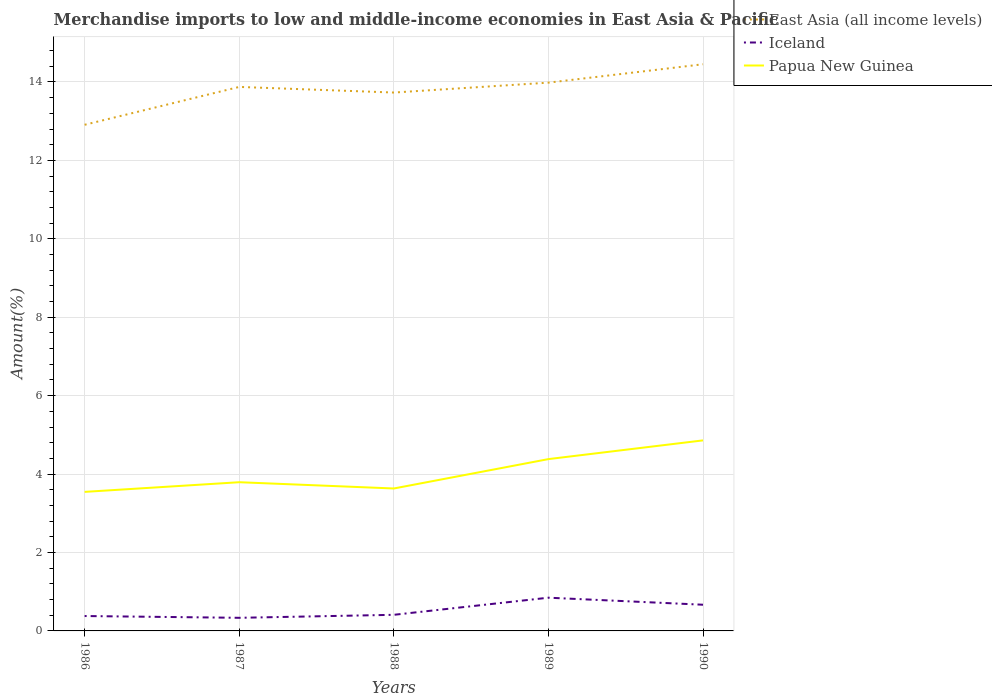How many different coloured lines are there?
Offer a very short reply. 3. Does the line corresponding to Papua New Guinea intersect with the line corresponding to Iceland?
Your response must be concise. No. Across all years, what is the maximum percentage of amount earned from merchandise imports in Iceland?
Make the answer very short. 0.33. What is the total percentage of amount earned from merchandise imports in Papua New Guinea in the graph?
Provide a short and direct response. -0.84. What is the difference between the highest and the second highest percentage of amount earned from merchandise imports in East Asia (all income levels)?
Offer a very short reply. 1.54. Is the percentage of amount earned from merchandise imports in Papua New Guinea strictly greater than the percentage of amount earned from merchandise imports in East Asia (all income levels) over the years?
Offer a very short reply. Yes. How many lines are there?
Offer a terse response. 3. What is the difference between two consecutive major ticks on the Y-axis?
Offer a very short reply. 2. Where does the legend appear in the graph?
Offer a very short reply. Top right. How are the legend labels stacked?
Offer a very short reply. Vertical. What is the title of the graph?
Your answer should be very brief. Merchandise imports to low and middle-income economies in East Asia & Pacific. What is the label or title of the X-axis?
Your answer should be compact. Years. What is the label or title of the Y-axis?
Offer a very short reply. Amount(%). What is the Amount(%) of East Asia (all income levels) in 1986?
Offer a very short reply. 12.91. What is the Amount(%) of Iceland in 1986?
Provide a short and direct response. 0.38. What is the Amount(%) of Papua New Guinea in 1986?
Give a very brief answer. 3.55. What is the Amount(%) of East Asia (all income levels) in 1987?
Your response must be concise. 13.87. What is the Amount(%) in Iceland in 1987?
Your response must be concise. 0.33. What is the Amount(%) in Papua New Guinea in 1987?
Offer a very short reply. 3.79. What is the Amount(%) in East Asia (all income levels) in 1988?
Offer a terse response. 13.73. What is the Amount(%) of Iceland in 1988?
Offer a terse response. 0.41. What is the Amount(%) of Papua New Guinea in 1988?
Provide a succinct answer. 3.63. What is the Amount(%) of East Asia (all income levels) in 1989?
Your answer should be very brief. 13.98. What is the Amount(%) of Iceland in 1989?
Make the answer very short. 0.85. What is the Amount(%) of Papua New Guinea in 1989?
Your response must be concise. 4.38. What is the Amount(%) of East Asia (all income levels) in 1990?
Provide a succinct answer. 14.45. What is the Amount(%) of Iceland in 1990?
Make the answer very short. 0.67. What is the Amount(%) of Papua New Guinea in 1990?
Your answer should be very brief. 4.86. Across all years, what is the maximum Amount(%) in East Asia (all income levels)?
Your answer should be very brief. 14.45. Across all years, what is the maximum Amount(%) in Iceland?
Ensure brevity in your answer.  0.85. Across all years, what is the maximum Amount(%) of Papua New Guinea?
Your response must be concise. 4.86. Across all years, what is the minimum Amount(%) in East Asia (all income levels)?
Make the answer very short. 12.91. Across all years, what is the minimum Amount(%) of Iceland?
Offer a terse response. 0.33. Across all years, what is the minimum Amount(%) of Papua New Guinea?
Give a very brief answer. 3.55. What is the total Amount(%) in East Asia (all income levels) in the graph?
Ensure brevity in your answer.  68.94. What is the total Amount(%) in Iceland in the graph?
Give a very brief answer. 2.64. What is the total Amount(%) in Papua New Guinea in the graph?
Keep it short and to the point. 20.21. What is the difference between the Amount(%) in East Asia (all income levels) in 1986 and that in 1987?
Make the answer very short. -0.97. What is the difference between the Amount(%) of Iceland in 1986 and that in 1987?
Make the answer very short. 0.05. What is the difference between the Amount(%) of Papua New Guinea in 1986 and that in 1987?
Your response must be concise. -0.25. What is the difference between the Amount(%) of East Asia (all income levels) in 1986 and that in 1988?
Give a very brief answer. -0.82. What is the difference between the Amount(%) in Iceland in 1986 and that in 1988?
Keep it short and to the point. -0.03. What is the difference between the Amount(%) in Papua New Guinea in 1986 and that in 1988?
Give a very brief answer. -0.09. What is the difference between the Amount(%) of East Asia (all income levels) in 1986 and that in 1989?
Offer a very short reply. -1.07. What is the difference between the Amount(%) of Iceland in 1986 and that in 1989?
Make the answer very short. -0.47. What is the difference between the Amount(%) in Papua New Guinea in 1986 and that in 1989?
Offer a terse response. -0.84. What is the difference between the Amount(%) of East Asia (all income levels) in 1986 and that in 1990?
Provide a succinct answer. -1.54. What is the difference between the Amount(%) of Iceland in 1986 and that in 1990?
Give a very brief answer. -0.29. What is the difference between the Amount(%) of Papua New Guinea in 1986 and that in 1990?
Provide a short and direct response. -1.31. What is the difference between the Amount(%) in East Asia (all income levels) in 1987 and that in 1988?
Keep it short and to the point. 0.14. What is the difference between the Amount(%) of Iceland in 1987 and that in 1988?
Your answer should be very brief. -0.08. What is the difference between the Amount(%) in Papua New Guinea in 1987 and that in 1988?
Provide a short and direct response. 0.16. What is the difference between the Amount(%) in East Asia (all income levels) in 1987 and that in 1989?
Provide a succinct answer. -0.11. What is the difference between the Amount(%) in Iceland in 1987 and that in 1989?
Keep it short and to the point. -0.51. What is the difference between the Amount(%) in Papua New Guinea in 1987 and that in 1989?
Your answer should be compact. -0.59. What is the difference between the Amount(%) in East Asia (all income levels) in 1987 and that in 1990?
Offer a very short reply. -0.58. What is the difference between the Amount(%) in Iceland in 1987 and that in 1990?
Your answer should be compact. -0.33. What is the difference between the Amount(%) in Papua New Guinea in 1987 and that in 1990?
Your response must be concise. -1.07. What is the difference between the Amount(%) in East Asia (all income levels) in 1988 and that in 1989?
Keep it short and to the point. -0.25. What is the difference between the Amount(%) of Iceland in 1988 and that in 1989?
Give a very brief answer. -0.44. What is the difference between the Amount(%) of Papua New Guinea in 1988 and that in 1989?
Provide a short and direct response. -0.75. What is the difference between the Amount(%) in East Asia (all income levels) in 1988 and that in 1990?
Provide a short and direct response. -0.72. What is the difference between the Amount(%) of Iceland in 1988 and that in 1990?
Your answer should be compact. -0.26. What is the difference between the Amount(%) in Papua New Guinea in 1988 and that in 1990?
Ensure brevity in your answer.  -1.23. What is the difference between the Amount(%) of East Asia (all income levels) in 1989 and that in 1990?
Provide a succinct answer. -0.47. What is the difference between the Amount(%) of Iceland in 1989 and that in 1990?
Make the answer very short. 0.18. What is the difference between the Amount(%) in Papua New Guinea in 1989 and that in 1990?
Your response must be concise. -0.48. What is the difference between the Amount(%) of East Asia (all income levels) in 1986 and the Amount(%) of Iceland in 1987?
Make the answer very short. 12.57. What is the difference between the Amount(%) of East Asia (all income levels) in 1986 and the Amount(%) of Papua New Guinea in 1987?
Make the answer very short. 9.12. What is the difference between the Amount(%) of Iceland in 1986 and the Amount(%) of Papua New Guinea in 1987?
Give a very brief answer. -3.41. What is the difference between the Amount(%) in East Asia (all income levels) in 1986 and the Amount(%) in Iceland in 1988?
Ensure brevity in your answer.  12.5. What is the difference between the Amount(%) of East Asia (all income levels) in 1986 and the Amount(%) of Papua New Guinea in 1988?
Keep it short and to the point. 9.28. What is the difference between the Amount(%) of Iceland in 1986 and the Amount(%) of Papua New Guinea in 1988?
Provide a succinct answer. -3.25. What is the difference between the Amount(%) of East Asia (all income levels) in 1986 and the Amount(%) of Iceland in 1989?
Your answer should be very brief. 12.06. What is the difference between the Amount(%) in East Asia (all income levels) in 1986 and the Amount(%) in Papua New Guinea in 1989?
Provide a succinct answer. 8.53. What is the difference between the Amount(%) in Iceland in 1986 and the Amount(%) in Papua New Guinea in 1989?
Your answer should be compact. -4. What is the difference between the Amount(%) of East Asia (all income levels) in 1986 and the Amount(%) of Iceland in 1990?
Make the answer very short. 12.24. What is the difference between the Amount(%) in East Asia (all income levels) in 1986 and the Amount(%) in Papua New Guinea in 1990?
Make the answer very short. 8.05. What is the difference between the Amount(%) of Iceland in 1986 and the Amount(%) of Papua New Guinea in 1990?
Your answer should be compact. -4.48. What is the difference between the Amount(%) of East Asia (all income levels) in 1987 and the Amount(%) of Iceland in 1988?
Your answer should be compact. 13.46. What is the difference between the Amount(%) of East Asia (all income levels) in 1987 and the Amount(%) of Papua New Guinea in 1988?
Keep it short and to the point. 10.24. What is the difference between the Amount(%) in Iceland in 1987 and the Amount(%) in Papua New Guinea in 1988?
Your response must be concise. -3.3. What is the difference between the Amount(%) of East Asia (all income levels) in 1987 and the Amount(%) of Iceland in 1989?
Make the answer very short. 13.03. What is the difference between the Amount(%) of East Asia (all income levels) in 1987 and the Amount(%) of Papua New Guinea in 1989?
Your answer should be very brief. 9.49. What is the difference between the Amount(%) of Iceland in 1987 and the Amount(%) of Papua New Guinea in 1989?
Provide a succinct answer. -4.05. What is the difference between the Amount(%) of East Asia (all income levels) in 1987 and the Amount(%) of Iceland in 1990?
Give a very brief answer. 13.21. What is the difference between the Amount(%) of East Asia (all income levels) in 1987 and the Amount(%) of Papua New Guinea in 1990?
Give a very brief answer. 9.01. What is the difference between the Amount(%) of Iceland in 1987 and the Amount(%) of Papua New Guinea in 1990?
Provide a short and direct response. -4.52. What is the difference between the Amount(%) of East Asia (all income levels) in 1988 and the Amount(%) of Iceland in 1989?
Make the answer very short. 12.88. What is the difference between the Amount(%) in East Asia (all income levels) in 1988 and the Amount(%) in Papua New Guinea in 1989?
Offer a very short reply. 9.35. What is the difference between the Amount(%) of Iceland in 1988 and the Amount(%) of Papua New Guinea in 1989?
Offer a very short reply. -3.97. What is the difference between the Amount(%) of East Asia (all income levels) in 1988 and the Amount(%) of Iceland in 1990?
Your response must be concise. 13.06. What is the difference between the Amount(%) of East Asia (all income levels) in 1988 and the Amount(%) of Papua New Guinea in 1990?
Provide a succinct answer. 8.87. What is the difference between the Amount(%) of Iceland in 1988 and the Amount(%) of Papua New Guinea in 1990?
Provide a succinct answer. -4.45. What is the difference between the Amount(%) in East Asia (all income levels) in 1989 and the Amount(%) in Iceland in 1990?
Your response must be concise. 13.31. What is the difference between the Amount(%) of East Asia (all income levels) in 1989 and the Amount(%) of Papua New Guinea in 1990?
Your answer should be very brief. 9.12. What is the difference between the Amount(%) of Iceland in 1989 and the Amount(%) of Papua New Guinea in 1990?
Your answer should be compact. -4.01. What is the average Amount(%) of East Asia (all income levels) per year?
Your answer should be compact. 13.79. What is the average Amount(%) of Iceland per year?
Your answer should be compact. 0.53. What is the average Amount(%) in Papua New Guinea per year?
Give a very brief answer. 4.04. In the year 1986, what is the difference between the Amount(%) of East Asia (all income levels) and Amount(%) of Iceland?
Your response must be concise. 12.53. In the year 1986, what is the difference between the Amount(%) in East Asia (all income levels) and Amount(%) in Papua New Guinea?
Provide a succinct answer. 9.36. In the year 1986, what is the difference between the Amount(%) of Iceland and Amount(%) of Papua New Guinea?
Offer a terse response. -3.17. In the year 1987, what is the difference between the Amount(%) in East Asia (all income levels) and Amount(%) in Iceland?
Make the answer very short. 13.54. In the year 1987, what is the difference between the Amount(%) of East Asia (all income levels) and Amount(%) of Papua New Guinea?
Provide a succinct answer. 10.08. In the year 1987, what is the difference between the Amount(%) of Iceland and Amount(%) of Papua New Guinea?
Provide a short and direct response. -3.46. In the year 1988, what is the difference between the Amount(%) of East Asia (all income levels) and Amount(%) of Iceland?
Offer a terse response. 13.32. In the year 1988, what is the difference between the Amount(%) in East Asia (all income levels) and Amount(%) in Papua New Guinea?
Your answer should be compact. 10.1. In the year 1988, what is the difference between the Amount(%) of Iceland and Amount(%) of Papua New Guinea?
Your answer should be compact. -3.22. In the year 1989, what is the difference between the Amount(%) in East Asia (all income levels) and Amount(%) in Iceland?
Offer a terse response. 13.13. In the year 1989, what is the difference between the Amount(%) in East Asia (all income levels) and Amount(%) in Papua New Guinea?
Provide a succinct answer. 9.6. In the year 1989, what is the difference between the Amount(%) of Iceland and Amount(%) of Papua New Guinea?
Give a very brief answer. -3.53. In the year 1990, what is the difference between the Amount(%) in East Asia (all income levels) and Amount(%) in Iceland?
Provide a succinct answer. 13.78. In the year 1990, what is the difference between the Amount(%) of East Asia (all income levels) and Amount(%) of Papua New Guinea?
Your answer should be very brief. 9.59. In the year 1990, what is the difference between the Amount(%) of Iceland and Amount(%) of Papua New Guinea?
Make the answer very short. -4.19. What is the ratio of the Amount(%) of East Asia (all income levels) in 1986 to that in 1987?
Give a very brief answer. 0.93. What is the ratio of the Amount(%) of Iceland in 1986 to that in 1987?
Your answer should be very brief. 1.14. What is the ratio of the Amount(%) in Papua New Guinea in 1986 to that in 1987?
Provide a short and direct response. 0.94. What is the ratio of the Amount(%) in East Asia (all income levels) in 1986 to that in 1988?
Ensure brevity in your answer.  0.94. What is the ratio of the Amount(%) of Iceland in 1986 to that in 1988?
Give a very brief answer. 0.92. What is the ratio of the Amount(%) of Papua New Guinea in 1986 to that in 1988?
Your response must be concise. 0.98. What is the ratio of the Amount(%) in Iceland in 1986 to that in 1989?
Make the answer very short. 0.45. What is the ratio of the Amount(%) in Papua New Guinea in 1986 to that in 1989?
Offer a very short reply. 0.81. What is the ratio of the Amount(%) of East Asia (all income levels) in 1986 to that in 1990?
Offer a terse response. 0.89. What is the ratio of the Amount(%) of Iceland in 1986 to that in 1990?
Give a very brief answer. 0.57. What is the ratio of the Amount(%) in Papua New Guinea in 1986 to that in 1990?
Offer a terse response. 0.73. What is the ratio of the Amount(%) of East Asia (all income levels) in 1987 to that in 1988?
Offer a very short reply. 1.01. What is the ratio of the Amount(%) of Iceland in 1987 to that in 1988?
Ensure brevity in your answer.  0.81. What is the ratio of the Amount(%) of Papua New Guinea in 1987 to that in 1988?
Your response must be concise. 1.04. What is the ratio of the Amount(%) of Iceland in 1987 to that in 1989?
Your answer should be compact. 0.39. What is the ratio of the Amount(%) in Papua New Guinea in 1987 to that in 1989?
Your response must be concise. 0.87. What is the ratio of the Amount(%) in East Asia (all income levels) in 1987 to that in 1990?
Give a very brief answer. 0.96. What is the ratio of the Amount(%) in Iceland in 1987 to that in 1990?
Offer a terse response. 0.5. What is the ratio of the Amount(%) in Papua New Guinea in 1987 to that in 1990?
Offer a very short reply. 0.78. What is the ratio of the Amount(%) of East Asia (all income levels) in 1988 to that in 1989?
Offer a terse response. 0.98. What is the ratio of the Amount(%) of Iceland in 1988 to that in 1989?
Provide a short and direct response. 0.48. What is the ratio of the Amount(%) of Papua New Guinea in 1988 to that in 1989?
Provide a short and direct response. 0.83. What is the ratio of the Amount(%) in East Asia (all income levels) in 1988 to that in 1990?
Ensure brevity in your answer.  0.95. What is the ratio of the Amount(%) in Iceland in 1988 to that in 1990?
Your answer should be very brief. 0.61. What is the ratio of the Amount(%) of Papua New Guinea in 1988 to that in 1990?
Make the answer very short. 0.75. What is the ratio of the Amount(%) of East Asia (all income levels) in 1989 to that in 1990?
Make the answer very short. 0.97. What is the ratio of the Amount(%) in Iceland in 1989 to that in 1990?
Provide a succinct answer. 1.27. What is the ratio of the Amount(%) of Papua New Guinea in 1989 to that in 1990?
Give a very brief answer. 0.9. What is the difference between the highest and the second highest Amount(%) in East Asia (all income levels)?
Your answer should be very brief. 0.47. What is the difference between the highest and the second highest Amount(%) of Iceland?
Your answer should be compact. 0.18. What is the difference between the highest and the second highest Amount(%) of Papua New Guinea?
Provide a succinct answer. 0.48. What is the difference between the highest and the lowest Amount(%) of East Asia (all income levels)?
Offer a very short reply. 1.54. What is the difference between the highest and the lowest Amount(%) in Iceland?
Your answer should be very brief. 0.51. What is the difference between the highest and the lowest Amount(%) of Papua New Guinea?
Your answer should be very brief. 1.31. 